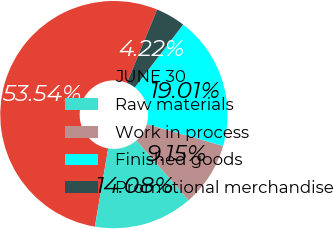Convert chart. <chart><loc_0><loc_0><loc_500><loc_500><pie_chart><fcel>JUNE 30<fcel>Raw materials<fcel>Work in process<fcel>Finished goods<fcel>Promotional merchandise<nl><fcel>53.53%<fcel>14.08%<fcel>9.15%<fcel>19.01%<fcel>4.22%<nl></chart> 